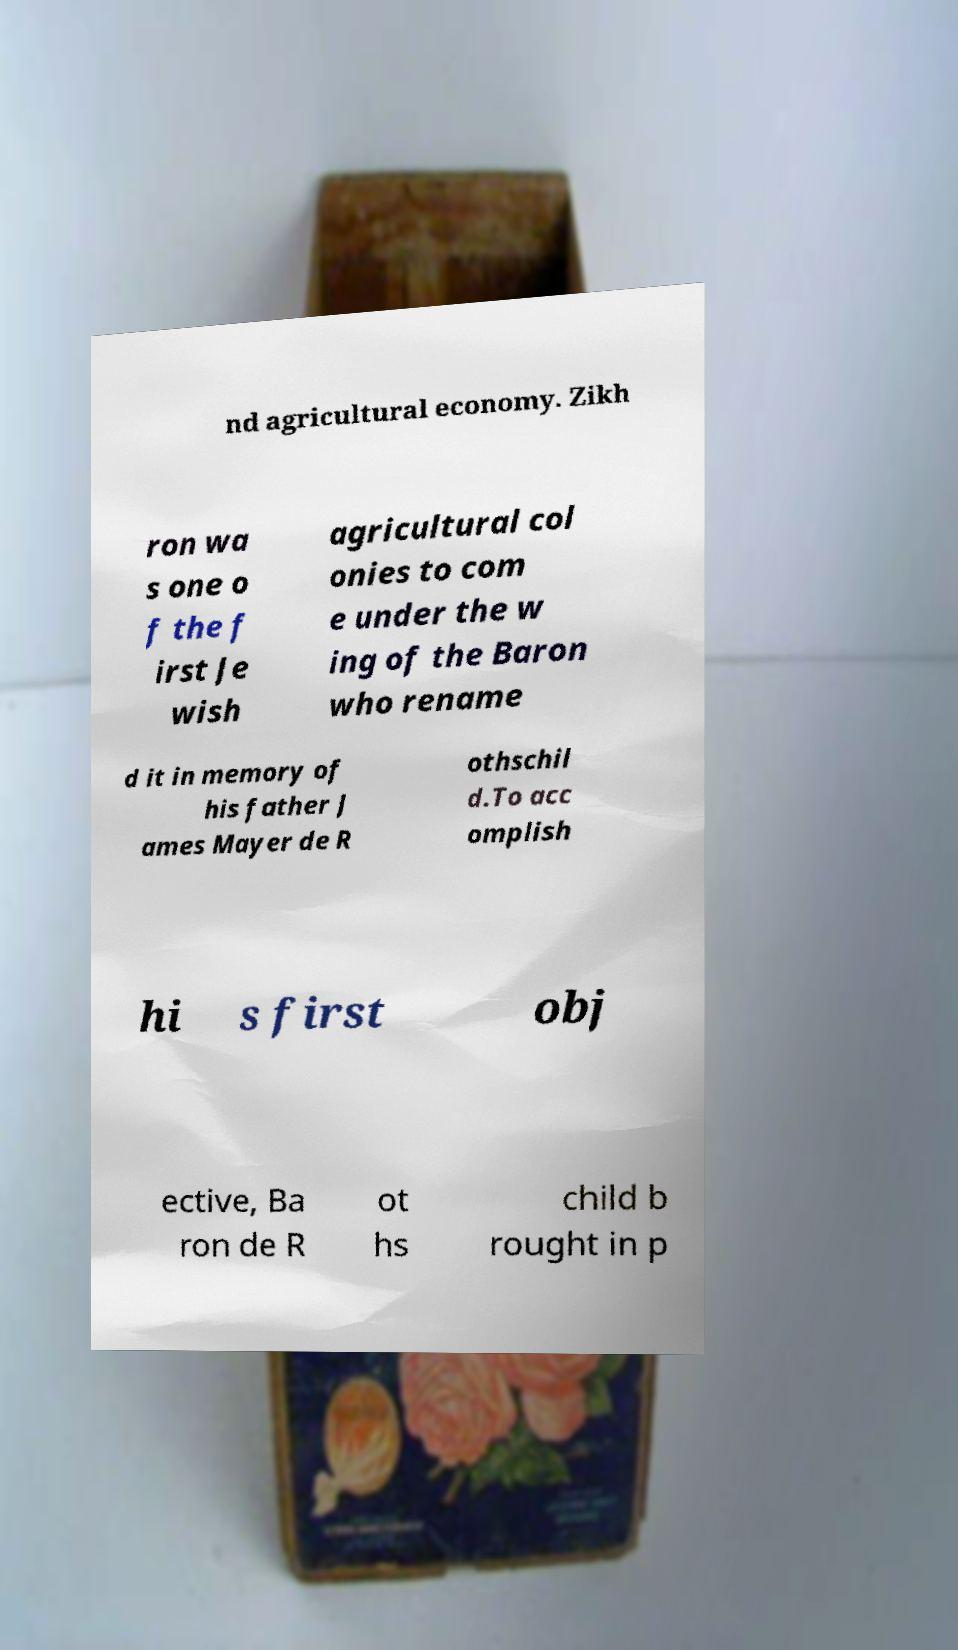Could you assist in decoding the text presented in this image and type it out clearly? nd agricultural economy. Zikh ron wa s one o f the f irst Je wish agricultural col onies to com e under the w ing of the Baron who rename d it in memory of his father J ames Mayer de R othschil d.To acc omplish hi s first obj ective, Ba ron de R ot hs child b rought in p 